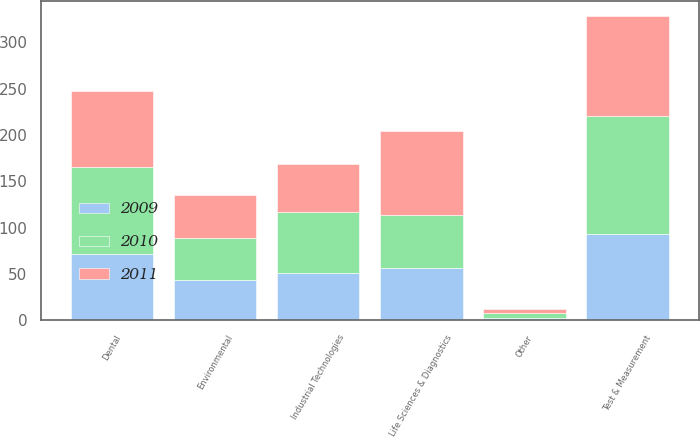Convert chart. <chart><loc_0><loc_0><loc_500><loc_500><stacked_bar_chart><ecel><fcel>Test & Measurement<fcel>Environmental<fcel>Life Sciences & Diagnostics<fcel>Dental<fcel>Industrial Technologies<fcel>Other<nl><fcel>2010<fcel>126.6<fcel>45.9<fcel>56.6<fcel>94<fcel>65.8<fcel>5.4<nl><fcel>2011<fcel>107.7<fcel>45.9<fcel>90.7<fcel>81.7<fcel>51.5<fcel>4.6<nl><fcel>2009<fcel>93.5<fcel>43.1<fcel>56.6<fcel>71.3<fcel>51.5<fcel>2<nl></chart> 